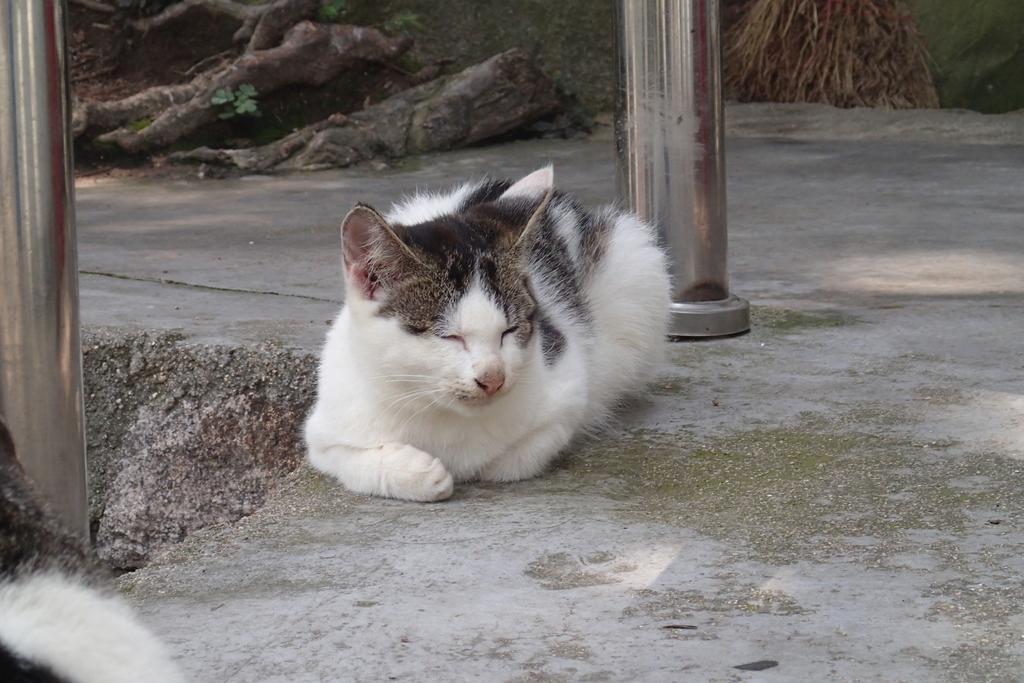Can you describe this image briefly? In this image there is a cat. Behind the cat there are wooden logs. There are pillars. On the left side of the image there is another cat. 